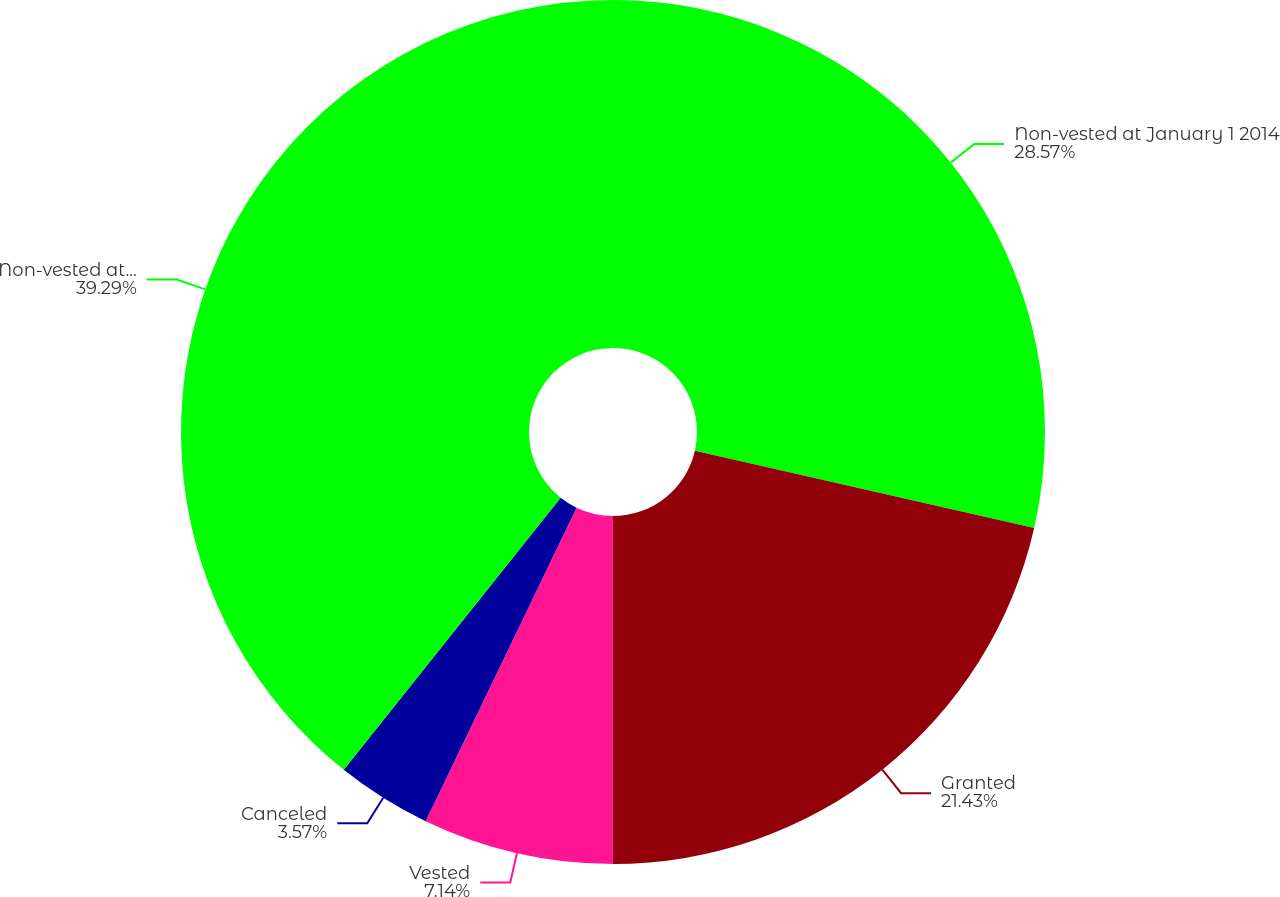Convert chart. <chart><loc_0><loc_0><loc_500><loc_500><pie_chart><fcel>Non-vested at January 1 2014<fcel>Granted<fcel>Vested<fcel>Canceled<fcel>Non-vested at December 31 2014<nl><fcel>28.57%<fcel>21.43%<fcel>7.14%<fcel>3.57%<fcel>39.29%<nl></chart> 